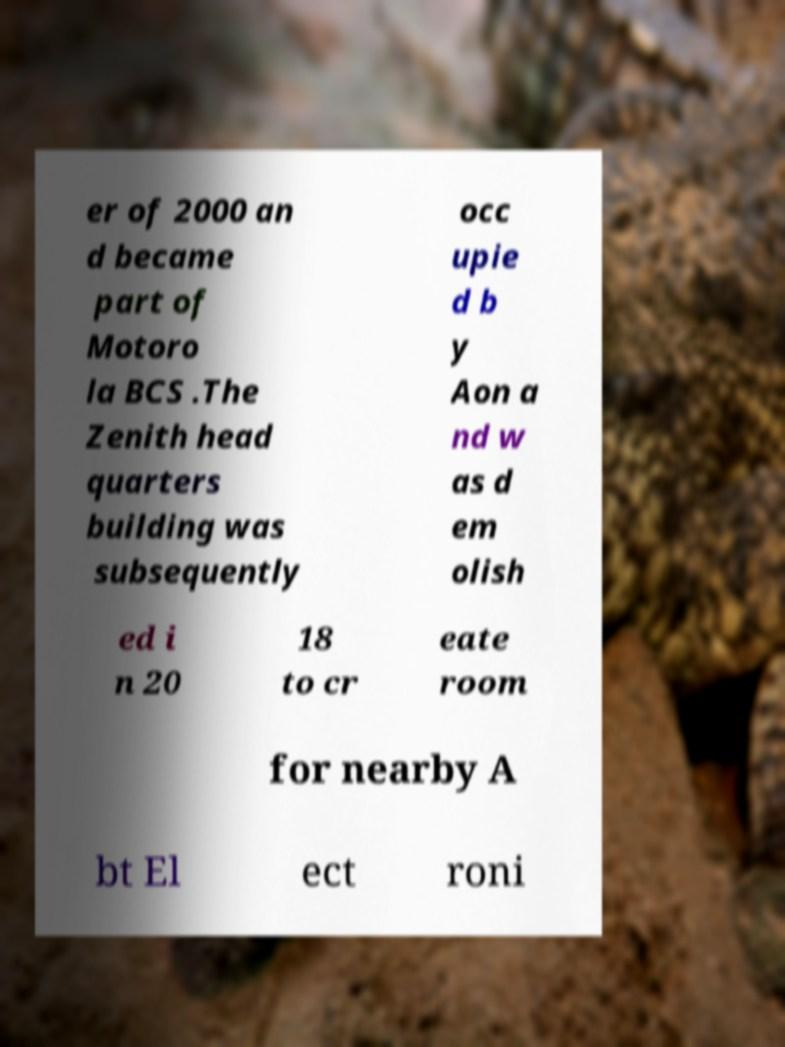Could you extract and type out the text from this image? er of 2000 an d became part of Motoro la BCS .The Zenith head quarters building was subsequently occ upie d b y Aon a nd w as d em olish ed i n 20 18 to cr eate room for nearby A bt El ect roni 